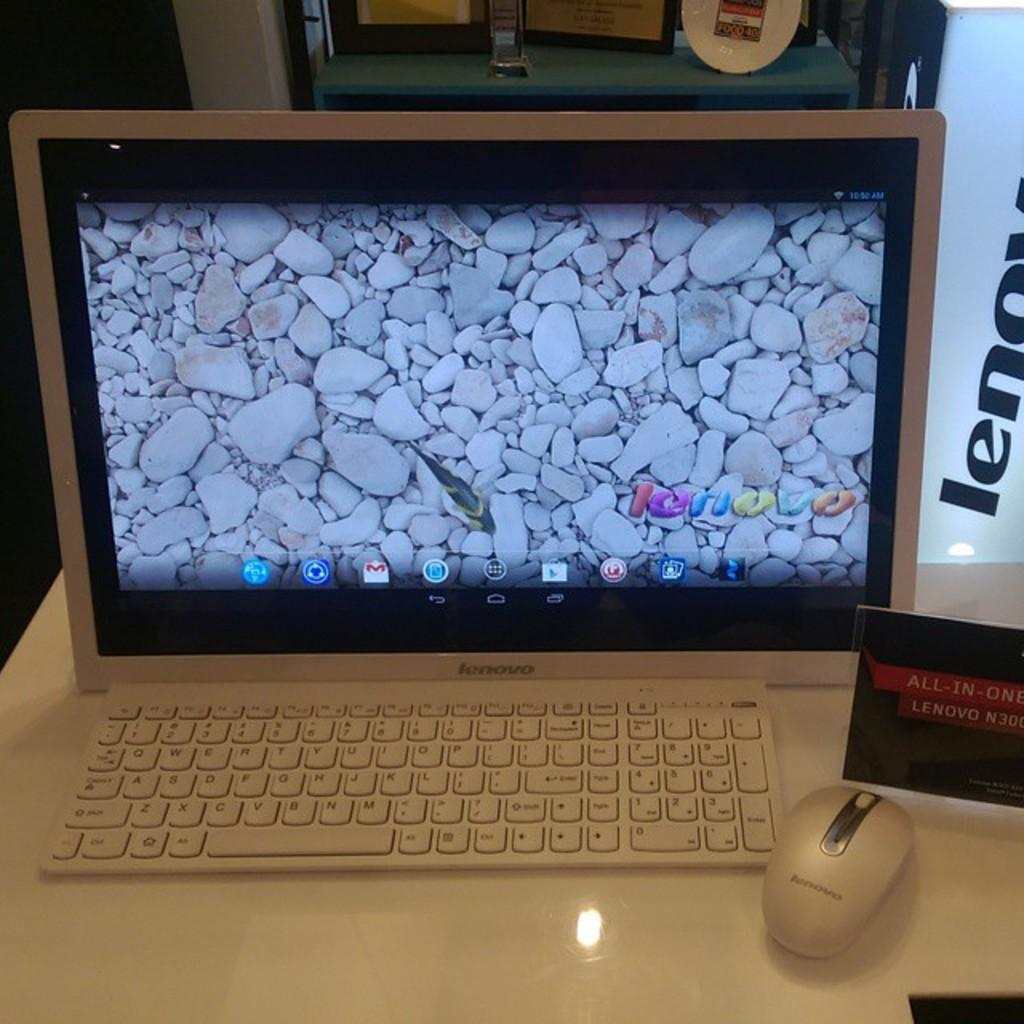<image>
Give a short and clear explanation of the subsequent image. A lenovo ALL-IN-ONE is shown with a bunch of rocks on the screen. 